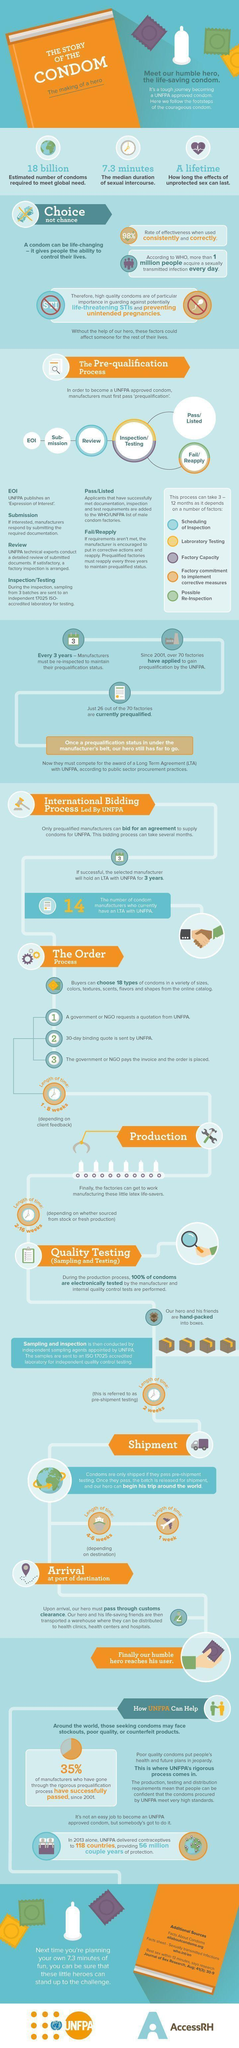What percent of factories are currently prequalified from among the number of factories applying since 2001?
Answer the question with a short phrase. 37.14% How many manufacturers have applied for an Long Term Agreement (LTA) from UNFPA since 2001? 40 